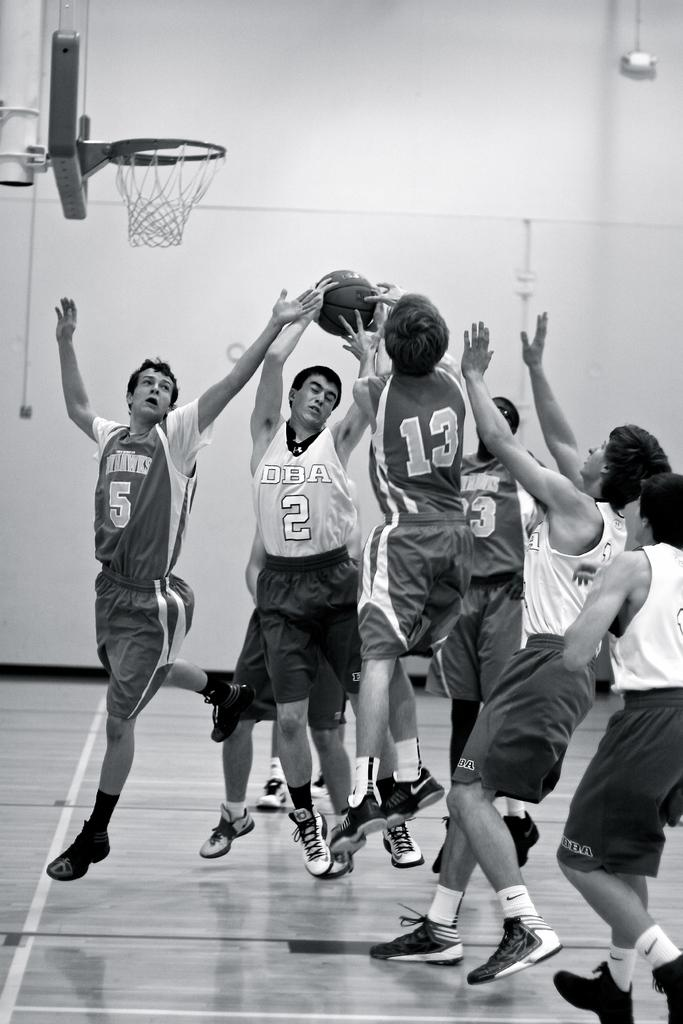What is the color scheme of the image? The image is black and white. What are the people in the image doing? The people are playing on the floor. What can be seen in the background of the image? There is a hoop and a rope in the background. What object is visible on the wall? There is an object on the wall. What is the main object being used by the people in the image? A ball is visible in the image. What type of pancake is being flipped in the image? There is no pancake present in the image; it features people playing on the floor with a ball. What baseball team are the people in the image supporting? There is no reference to a baseball team or any sports-related activity in the image. 